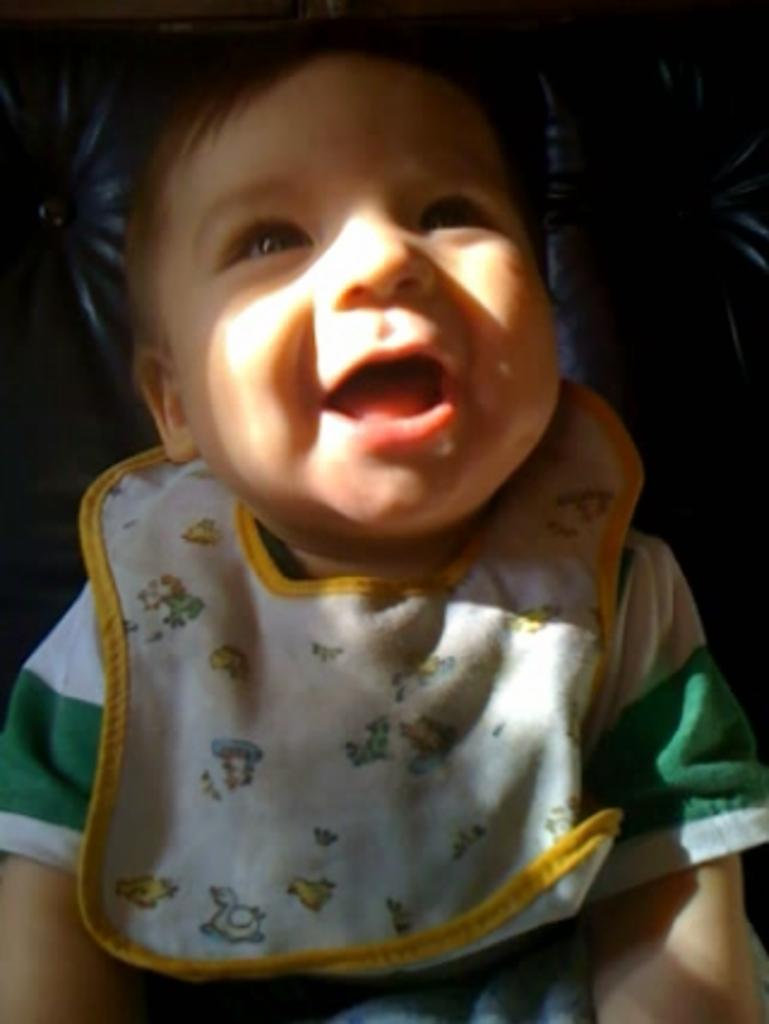What is the main subject of the image? There is a child in the image. What is the child wearing? The child is wearing a green color shirt. What type of fork can be seen in the child's hand in the image? There is no fork present in the image; the child is not holding anything. 